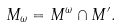<formula> <loc_0><loc_0><loc_500><loc_500>M _ { \omega } = M ^ { \omega } \cap M ^ { \prime } .</formula> 